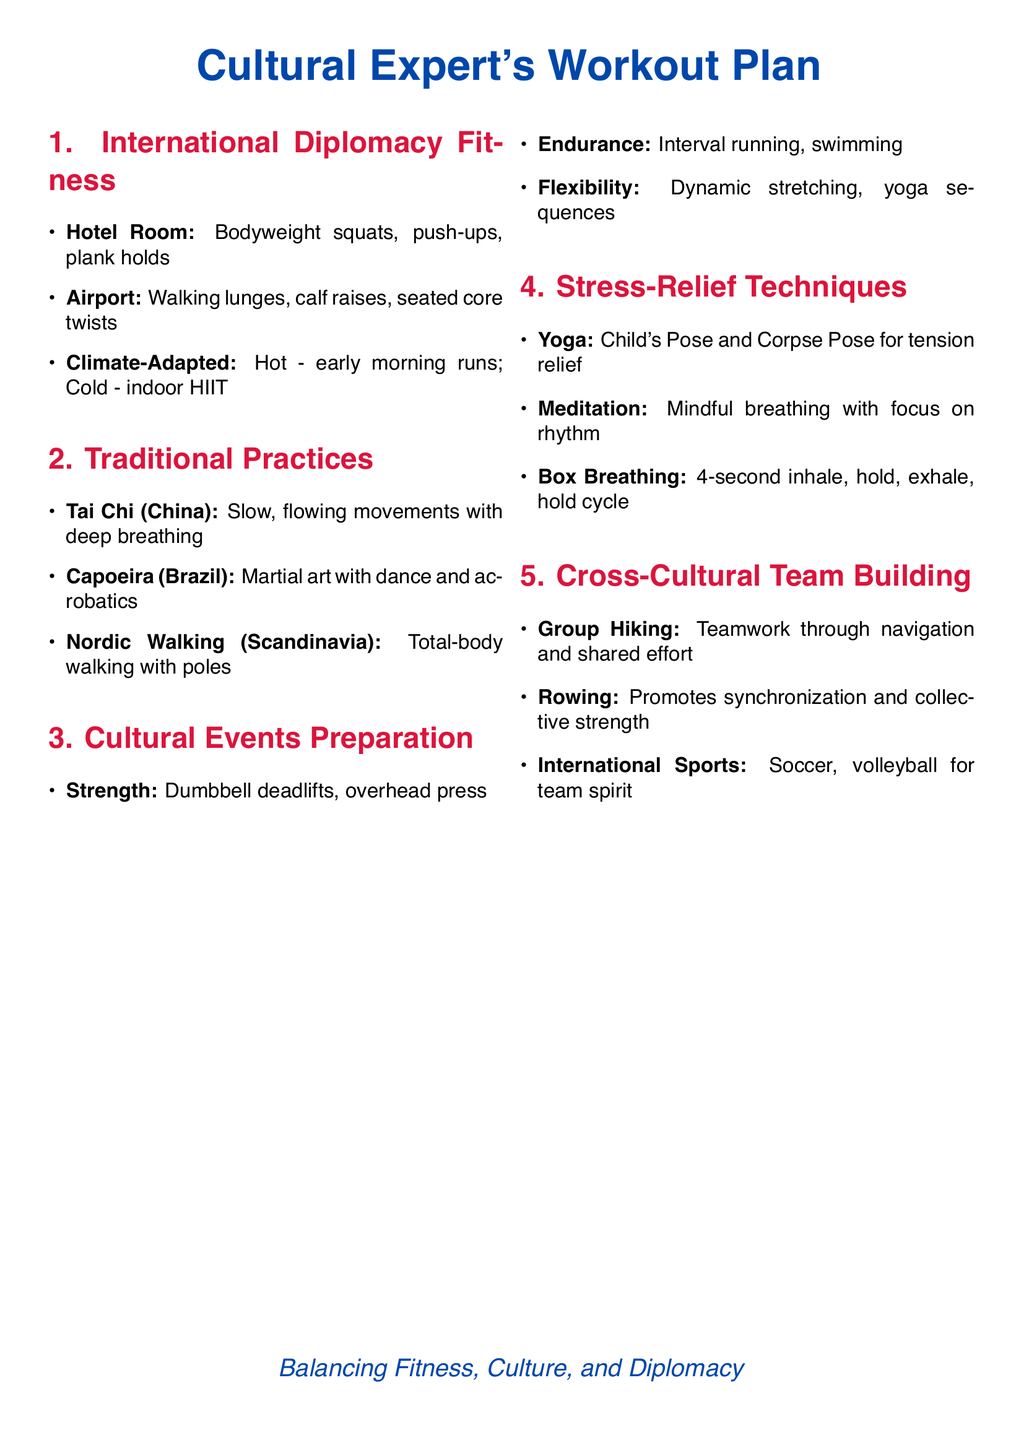What exercises can be done in a hotel room? The exercises listed for hotel rooms include bodyweight squats, push-ups, and plank holds.
Answer: Bodyweight squats, push-ups, plank holds What traditional exercise is associated with Brazil? The document mentions Capoeira as a traditional fitness practice from Brazil.
Answer: Capoeira What strength training exercise is recommended for cultural events? The document suggests dumbbell deadlifts as a strength training exercise for cultural events.
Answer: Dumbbell deadlifts Which stress-relief technique involves deep breathing? Mindful breathing as part of meditation is mentioned in the stress-relief section.
Answer: Meditation What is one cross-cultural team-building activity suggested? The document lists group hiking as a cross-cultural team-building exercise.
Answer: Group hiking How many sections are there in the workout plan? There are five sections outlined in the workout plan.
Answer: Five What cultural practice is characterized by slow, flowing movements? Tai Chi is described as a traditional practice characterized by slow, flowing movements.
Answer: Tai Chi Which exercise helps promote synchronization in a team setting? Rowing is cited as an exercise that promotes synchronization in a team.
Answer: Rowing 